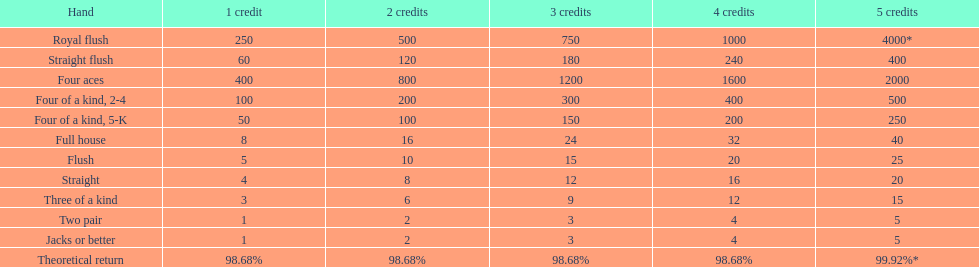What is the reward for obtaining a full house and winning using four credits? 32. 